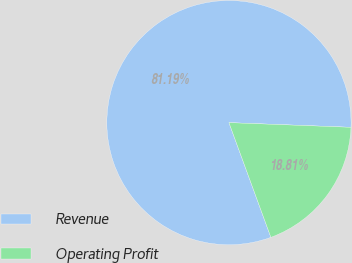<chart> <loc_0><loc_0><loc_500><loc_500><pie_chart><fcel>Revenue<fcel>Operating Profit<nl><fcel>81.19%<fcel>18.81%<nl></chart> 